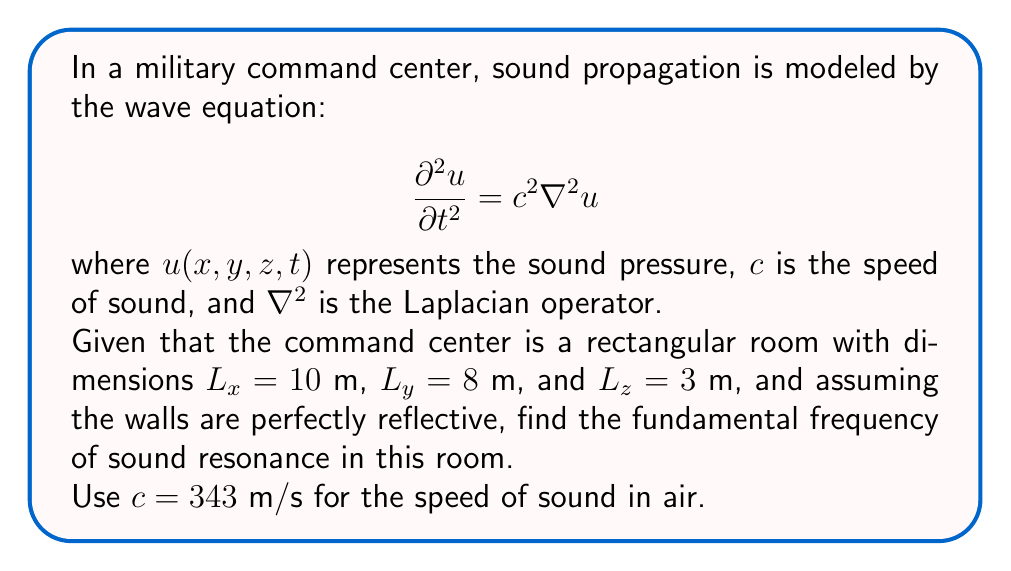Provide a solution to this math problem. To solve this problem, we'll follow these steps:

1) For a rectangular room with perfectly reflective walls, the solution to the wave equation takes the form:

   $$u(x,y,z,t) = A \cos(\omega t) \sin(k_x x) \sin(k_y y) \sin(k_z z)$$

   where $A$ is the amplitude, $\omega$ is the angular frequency, and $k_x$, $k_y$, and $k_z$ are the wave numbers in each direction.

2) The boundary conditions require that:

   $$k_x = \frac{n_x \pi}{L_x}, \quad k_y = \frac{n_y \pi}{L_y}, \quad k_z = \frac{n_z \pi}{L_z}$$

   where $n_x$, $n_y$, and $n_z$ are positive integers.

3) The dispersion relation for the wave equation connects $\omega$ and the wave numbers:

   $$\omega^2 = c^2(k_x^2 + k_y^2 + k_z^2)$$

4) Substituting the expressions for $k_x$, $k_y$, and $k_z$:

   $$\omega^2 = c^2 \pi^2 \left(\frac{n_x^2}{L_x^2} + \frac{n_y^2}{L_y^2} + \frac{n_z^2}{L_z^2}\right)$$

5) The fundamental frequency corresponds to the lowest possible frequency, which occurs when $n_x = n_y = n_z = 1$:

   $$f = \frac{\omega}{2\pi} = \frac{c}{2} \sqrt{\frac{1}{L_x^2} + \frac{1}{L_y^2} + \frac{1}{L_z^2}}$$

6) Substituting the given values:

   $$f = \frac{343}{2} \sqrt{\frac{1}{10^2} + \frac{1}{8^2} + \frac{1}{3^2}}$$

7) Calculating:

   $$f = 171.5 \sqrt{0.01 + 0.015625 + 0.111111} \approx 63.8 \text{ Hz}$$
Answer: 63.8 Hz 